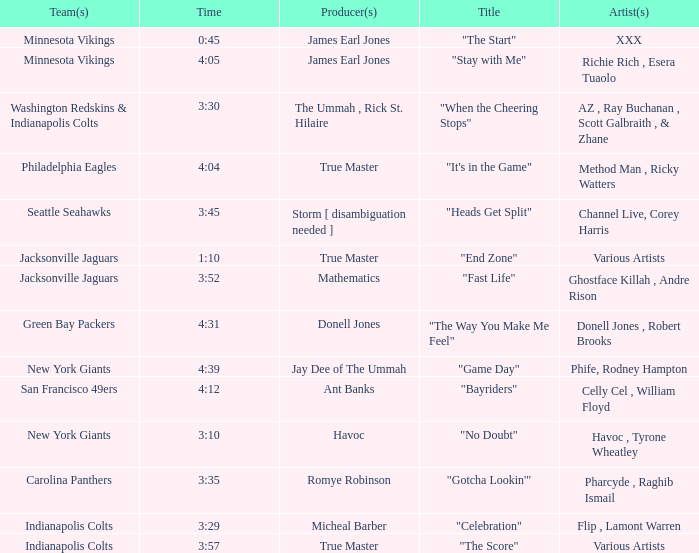Who is the composer of the seattle seahawks track? Channel Live, Corey Harris. Parse the table in full. {'header': ['Team(s)', 'Time', 'Producer(s)', 'Title', 'Artist(s)'], 'rows': [['Minnesota Vikings', '0:45', 'James Earl Jones', '"The Start"', 'XXX'], ['Minnesota Vikings', '4:05', 'James Earl Jones', '"Stay with Me"', 'Richie Rich , Esera Tuaolo'], ['Washington Redskins & Indianapolis Colts', '3:30', 'The Ummah , Rick St. Hilaire', '"When the Cheering Stops"', 'AZ , Ray Buchanan , Scott Galbraith , & Zhane'], ['Philadelphia Eagles', '4:04', 'True Master', '"It\'s in the Game"', 'Method Man , Ricky Watters'], ['Seattle Seahawks', '3:45', 'Storm [ disambiguation needed ]', '"Heads Get Split"', 'Channel Live, Corey Harris'], ['Jacksonville Jaguars', '1:10', 'True Master', '"End Zone"', 'Various Artists'], ['Jacksonville Jaguars', '3:52', 'Mathematics', '"Fast Life"', 'Ghostface Killah , Andre Rison'], ['Green Bay Packers', '4:31', 'Donell Jones', '"The Way You Make Me Feel"', 'Donell Jones , Robert Brooks'], ['New York Giants', '4:39', 'Jay Dee of The Ummah', '"Game Day"', 'Phife, Rodney Hampton'], ['San Francisco 49ers', '4:12', 'Ant Banks', '"Bayriders"', 'Celly Cel , William Floyd'], ['New York Giants', '3:10', 'Havoc', '"No Doubt"', 'Havoc , Tyrone Wheatley'], ['Carolina Panthers', '3:35', 'Romye Robinson', '"Gotcha Lookin\'"', 'Pharcyde , Raghib Ismail'], ['Indianapolis Colts', '3:29', 'Micheal Barber', '"Celebration"', 'Flip , Lamont Warren'], ['Indianapolis Colts', '3:57', 'True Master', '"The Score"', 'Various Artists']]} 